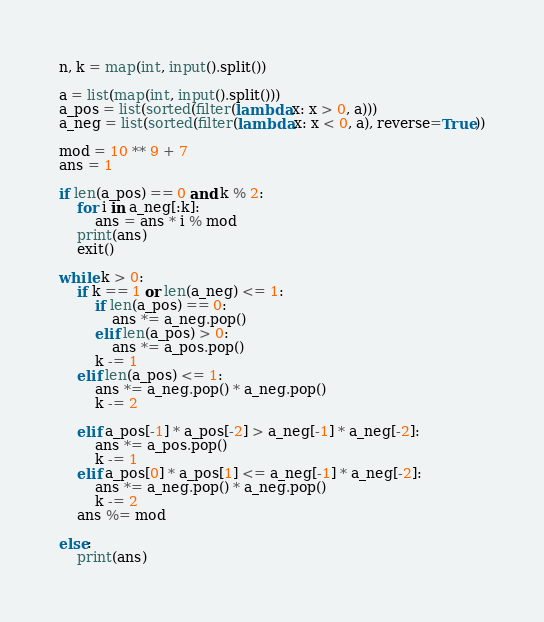<code> <loc_0><loc_0><loc_500><loc_500><_Python_>n, k = map(int, input().split())

a = list(map(int, input().split()))
a_pos = list(sorted(filter(lambda x: x > 0, a)))
a_neg = list(sorted(filter(lambda x: x < 0, a), reverse=True))

mod = 10 ** 9 + 7
ans = 1

if len(a_pos) == 0 and k % 2:
    for i in a_neg[:k]:
        ans = ans * i % mod
    print(ans)
    exit()

while k > 0:
    if k == 1 or len(a_neg) <= 1:
        if len(a_pos) == 0:
            ans *= a_neg.pop()
        elif len(a_pos) > 0:
            ans *= a_pos.pop()
        k -= 1
    elif len(a_pos) <= 1:
        ans *= a_neg.pop() * a_neg.pop()
        k -= 2
    
    elif a_pos[-1] * a_pos[-2] > a_neg[-1] * a_neg[-2]:
        ans *= a_pos.pop()
        k -= 1
    elif a_pos[0] * a_pos[1] <= a_neg[-1] * a_neg[-2]:
        ans *= a_neg.pop() * a_neg.pop()
        k -= 2
    ans %= mod

else:
    print(ans)</code> 